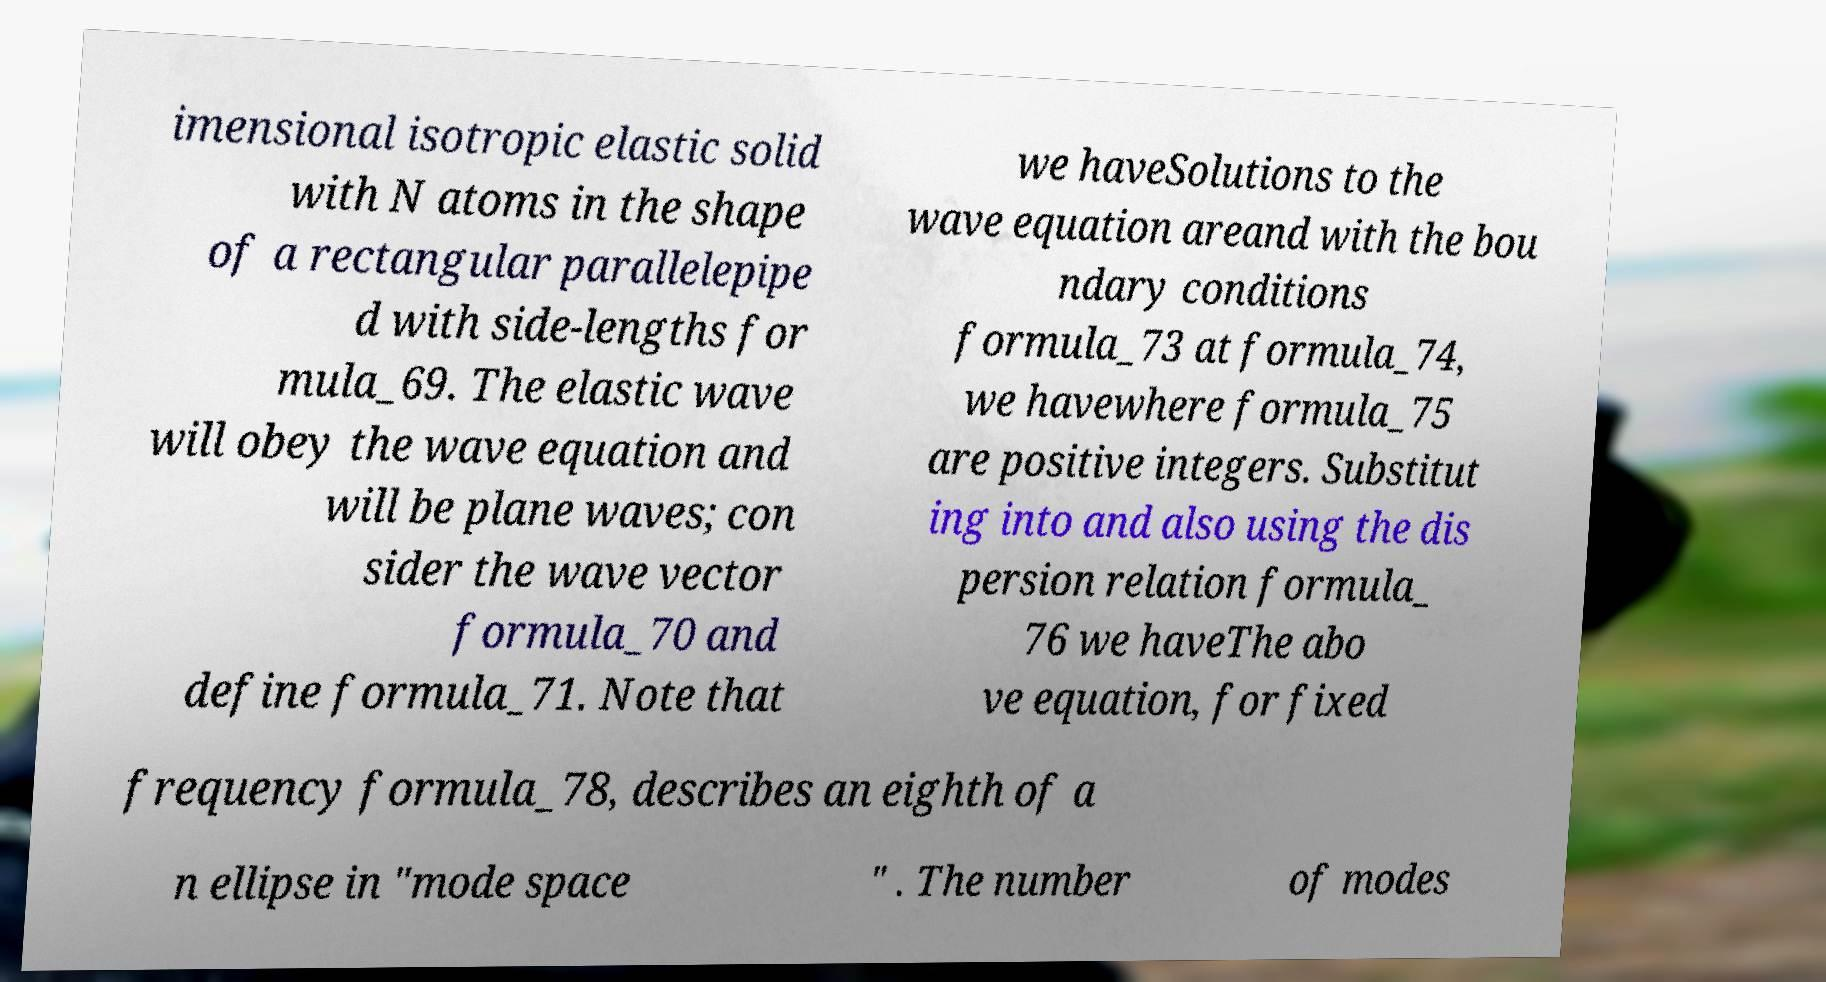Please identify and transcribe the text found in this image. imensional isotropic elastic solid with N atoms in the shape of a rectangular parallelepipe d with side-lengths for mula_69. The elastic wave will obey the wave equation and will be plane waves; con sider the wave vector formula_70 and define formula_71. Note that we haveSolutions to the wave equation areand with the bou ndary conditions formula_73 at formula_74, we havewhere formula_75 are positive integers. Substitut ing into and also using the dis persion relation formula_ 76 we haveThe abo ve equation, for fixed frequency formula_78, describes an eighth of a n ellipse in "mode space " . The number of modes 